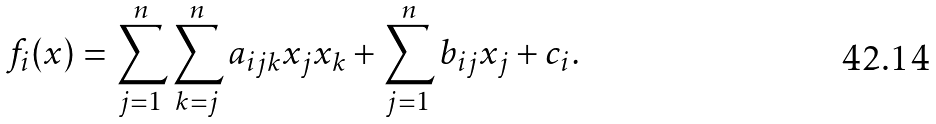Convert formula to latex. <formula><loc_0><loc_0><loc_500><loc_500>f _ { i } ( { x } ) = \sum _ { j = 1 } ^ { n } \sum _ { k = j } ^ { n } a _ { i j k } x _ { j } x _ { k } + \sum _ { j = 1 } ^ { n } b _ { i j } x _ { j } + c _ { i } .</formula> 